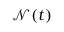Convert formula to latex. <formula><loc_0><loc_0><loc_500><loc_500>\mathcal { N } ( t )</formula> 